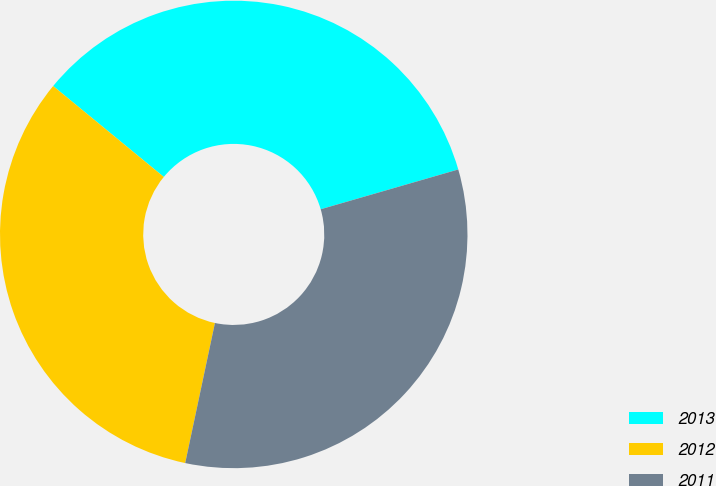Convert chart to OTSL. <chart><loc_0><loc_0><loc_500><loc_500><pie_chart><fcel>2013<fcel>2012<fcel>2011<nl><fcel>34.57%<fcel>32.62%<fcel>32.81%<nl></chart> 